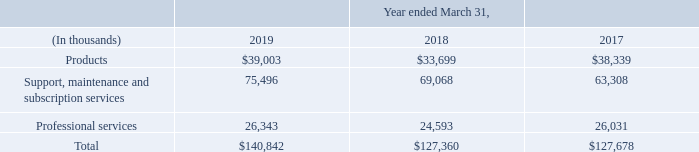Products, Support and Professional Services
We are a leading developer and marketer of software enabled solutions and services to the hospitality industry, including: software solutions fully integrated with third party hardware and operating systems; support, maintenance and subscription services; and, professional services. Areas of specialization are point of sale, property management, and a broad range of solutions that support the ecosystem of these core solutions.
We present revenue and costs of goods sold in three categories: • Products (hardware and software) • Support, maintenance and subscription services • Professional services
Total revenue for these three specific areas is as follows:
Products: Products revenue is comprised of revenue from the sale of software along with third party hardware and operating systems. Software sales include up front revenue for licensing our solutions on a perpetual basis. Software sales are driven by our solutions' ability to help our customer meet the demands of their guests and improve operating efficiencies. Our software revenue is also driven by the ability of our customers to configure our solutions for their specific needs and the robust catalog of integrations we offer to third party solutions. Our software solutions require varying form factors of third party hardware and operating systems to operate, such as staff facing terminals, kiosk solutions, mobile tablets or servers. Third party hardware and operating system revenue is typically driven by new customer wins and existing customer hardware refresh purchases.
Support, Maintenance and Subscription Services: Technical software support, software maintenance and software subscription services are a significant portion of our consolidated revenue and typically generate higher profit margins than products revenue. Growth has been driven by a strategic focus on developing and promoting these offerings while market demand for maintenance services and updates that enhance reliability, as well as the desire for flexibility in purchasing options, continue to reinforce this trend. Our commitment to exceptional service has enabled us to become a trusted partner with customers who wish to optimize the level of service they provide to their guests and maximize commerce opportunities both on premise and in the cloud.
Professional Services: We have industry-leading expertise in designing, implementing, integrating and installing customized solutions into both traditional and newly created platforms. For existing enterprises, we seamlessly integrate new systems and for start-ups and fast-growing customers, we become a partner that can manage large-scale rollouts and tight construction schedules. Our extensive experience ranges from staging equipment to phased rollouts as well as training staff to provide operational expertise to help achieve maximum effectiveness and efficiencies in a manner that saves our customers time and money.
What is product revenue comprised of? Products revenue is comprised of revenue from the sale of software along with third party hardware and operating systems. What is the Products revenue in 2019?
Answer scale should be: thousand. $39,003. What does the table show? Revenue and costs of goods sold in three categories: • products (hardware and software) • support, maintenance and subscription services • professional services. What is the increase / (decrease) in products from 2018 to 2019?
Answer scale should be: thousand. 39,003 - 33,699
Answer: 5304. What is the average Support, maintenance and subscription services for 2018-2019?
Answer scale should be: thousand. (75,496 + 69,068) / 2
Answer: 72282. What was the average Professional services for 2018-2019?
Answer scale should be: thousand. (26,343 + 24,593) / 2
Answer: 25468. 